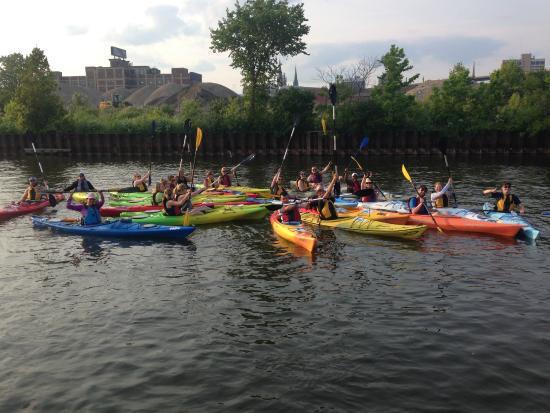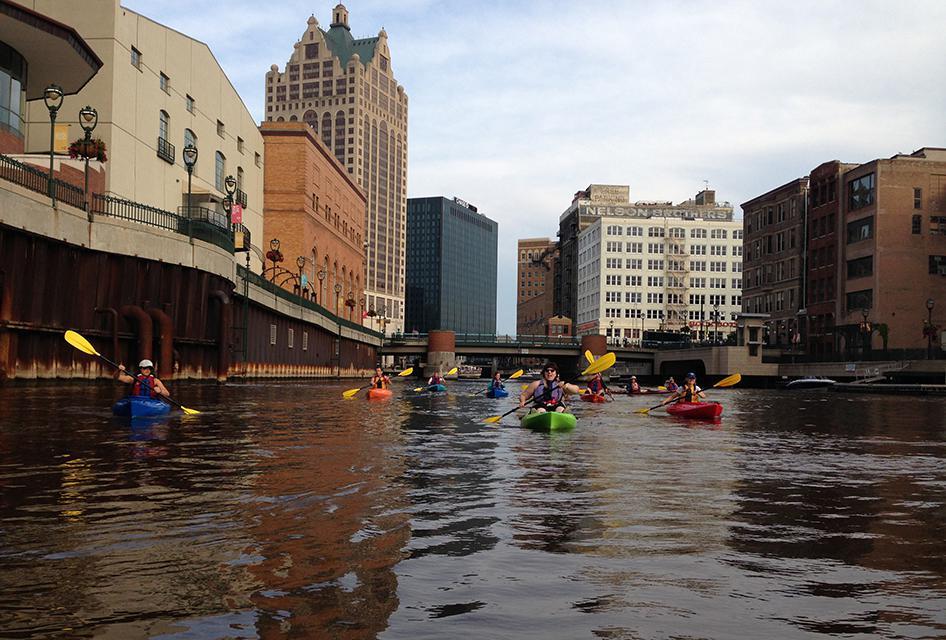The first image is the image on the left, the second image is the image on the right. For the images displayed, is the sentence "Multiple canoes are moving in one direction on a canal lined with buildings and with a bridge in the background." factually correct? Answer yes or no. Yes. The first image is the image on the left, the second image is the image on the right. Considering the images on both sides, is "There is exactly one boat in the right image." valid? Answer yes or no. No. 